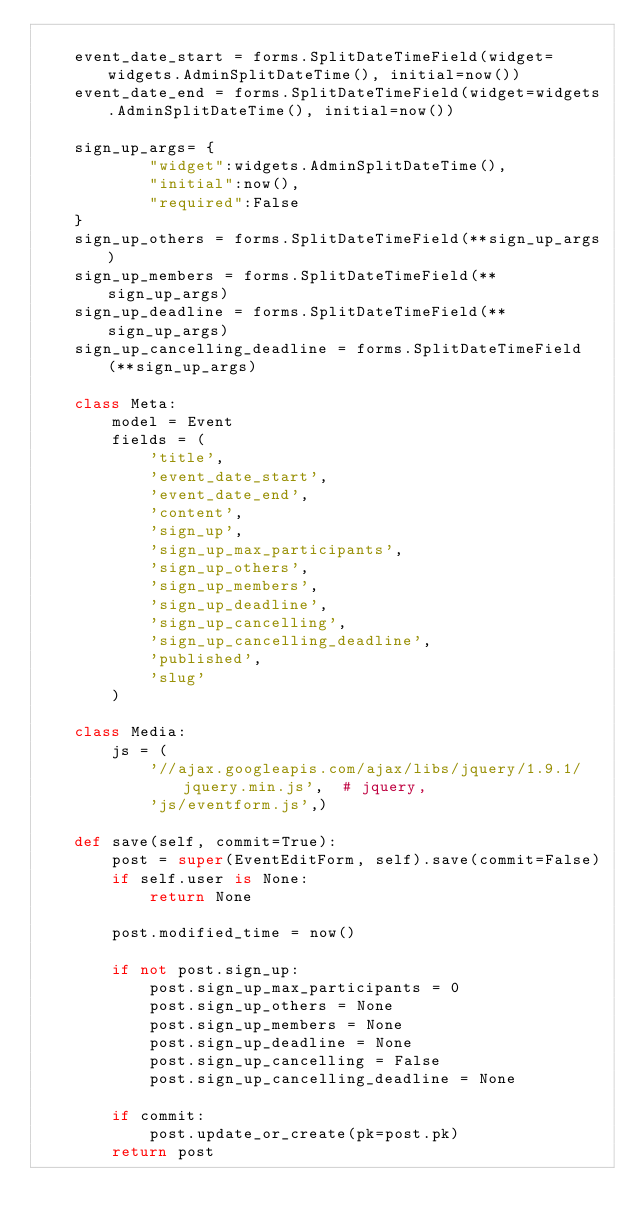<code> <loc_0><loc_0><loc_500><loc_500><_Python_>
    event_date_start = forms.SplitDateTimeField(widget=widgets.AdminSplitDateTime(), initial=now())
    event_date_end = forms.SplitDateTimeField(widget=widgets.AdminSplitDateTime(), initial=now())

    sign_up_args= {
            "widget":widgets.AdminSplitDateTime(),
            "initial":now(),
            "required":False
    }
    sign_up_others = forms.SplitDateTimeField(**sign_up_args)
    sign_up_members = forms.SplitDateTimeField(**sign_up_args)
    sign_up_deadline = forms.SplitDateTimeField(**sign_up_args)
    sign_up_cancelling_deadline = forms.SplitDateTimeField(**sign_up_args)

    class Meta:
        model = Event
        fields = (
            'title',
            'event_date_start',
            'event_date_end',
            'content',
            'sign_up',
            'sign_up_max_participants',
            'sign_up_others',
            'sign_up_members',
            'sign_up_deadline',
            'sign_up_cancelling',
            'sign_up_cancelling_deadline',
            'published',
            'slug'
        )

    class Media:
        js = (
            '//ajax.googleapis.com/ajax/libs/jquery/1.9.1/jquery.min.js',  # jquery,
            'js/eventform.js',)

    def save(self, commit=True):
        post = super(EventEditForm, self).save(commit=False)
        if self.user is None:
            return None

        post.modified_time = now()

        if not post.sign_up:
            post.sign_up_max_participants = 0
            post.sign_up_others = None
            post.sign_up_members = None
            post.sign_up_deadline = None
            post.sign_up_cancelling = False
            post.sign_up_cancelling_deadline = None

        if commit:
            post.update_or_create(pk=post.pk)
        return post
</code> 